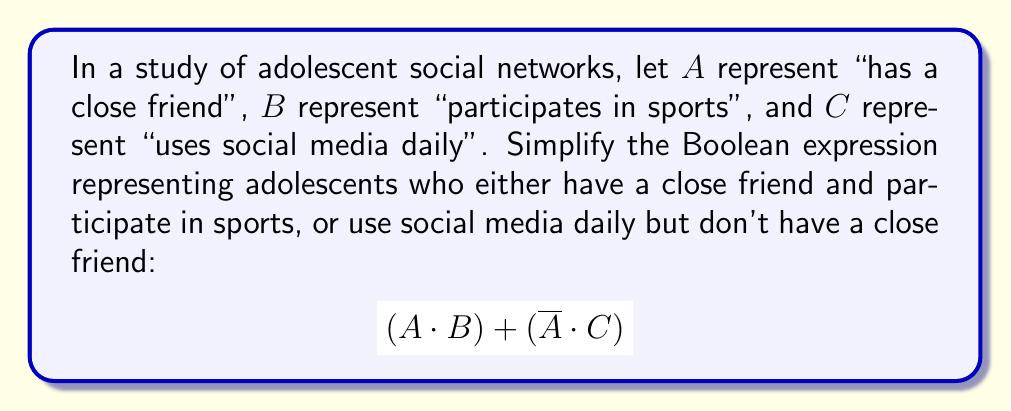Can you answer this question? To simplify this Boolean expression, we'll use the laws of Boolean algebra:

1) First, let's distribute $\overline{A}$ over C:
   $$(A \cdot B) + (\overline{A} \cdot C)$$

2) Now, we can apply the absorption law: $X + (\overline{X} \cdot Y) = X + Y$
   In this case, $X = A \cdot B$ and $Y = C$

3) Applying the absorption law:
   $$(A \cdot B) + C$$

4) This expression cannot be simplified further without losing information.

The final expression $(A \cdot B) + C$ represents adolescents who either:
- Have a close friend AND participate in sports, OR
- Use social media daily (regardless of their other characteristics)

This simplified form helps sociologists quickly identify the key factors in adolescent social connections within the studied group.
Answer: $(A \cdot B) + C$ 